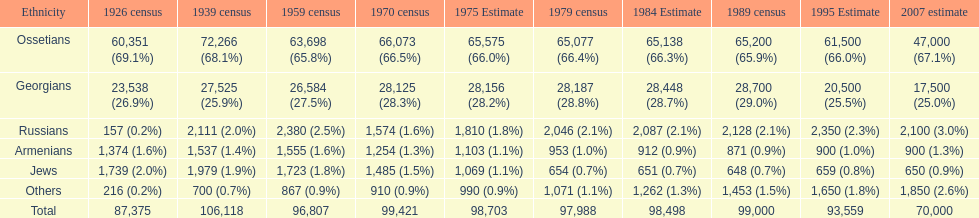How many russians lived in south ossetia in 1970? 1,574. 